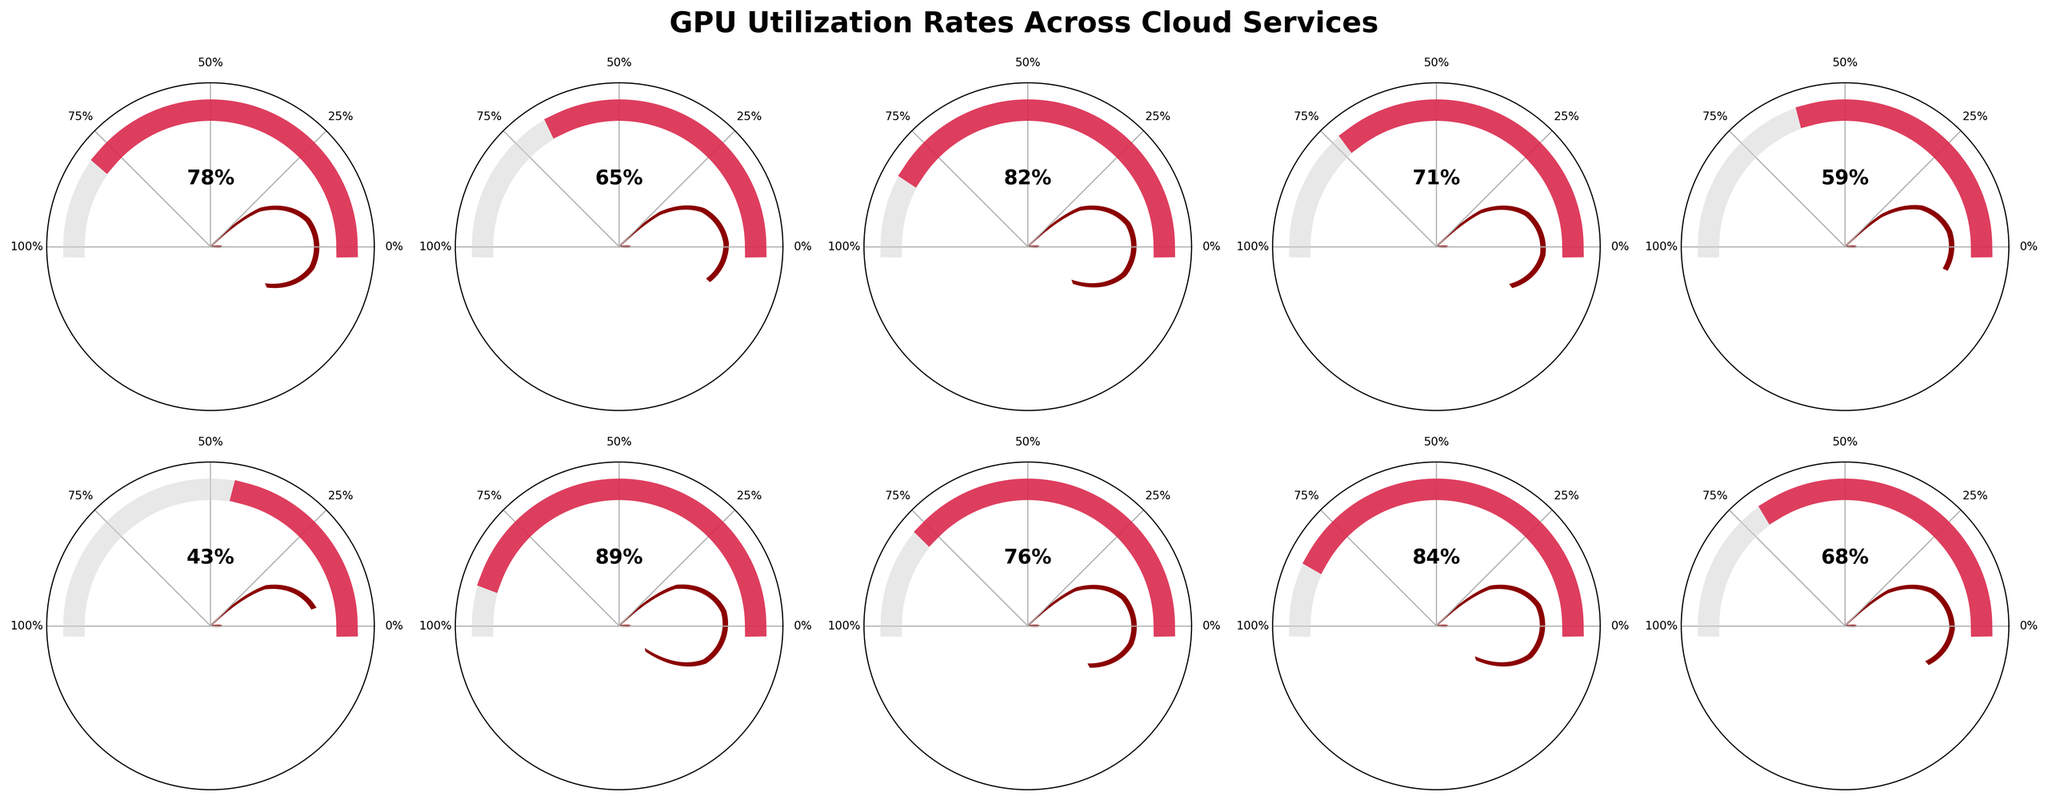What's the title of the figure? The title of the figure is shown at the top. It reads 'GPU Utilization Rates Across Cloud Services'.
Answer: GPU Utilization Rates Across Cloud Services How many cloud services are visualized in the figure? There are 10 different gauge charts displayed, each representing a distinct cloud service. So, there are 10 cloud services.
Answer: 10 Which cloud service has the highest GPU utilization rate? Looking at the gauge charts, AWS SageMaker shows the highest utilization rate, indicated by the needle at 89%.
Answer: AWS SageMaker What is the average GPU utilization rate among the services? Add all the utilization rates: 78 (AWS EC2) + 65 (Google Cloud GPU) + 82 (Azure GPU) + 71 (IBM Cloud GPU) + 59 (Oracle Cloud GPU) + 43 (Alibaba Cloud GPU) + 89 (AWS SageMaker) + 76 (Google Cloud TPU) + 84 (Azure Batch AI) + 68 (IBM Watson ML) = 715. Divide by the number of services, 10: 715/10 = 71.5
Answer: 71.5 Which application type is associated with the lowest GPU utilization rate, and what is its rate? Look for the lowest value among the gauge charts, which is 43%. This is associated with Alibaba Cloud GPU, used for Blockchain applications.
Answer: Blockchain and 43% Among services used for Machine Learning, Deep Learning, and Natural Language Processing, which ranks second in GPU utilization rate? The services and their rates are AWS EC2 (78%), AWS SageMaker (89%), and Google Cloud TPU (76%). The second highest is AWS EC2 at 78%.
Answer: AWS EC2 Are there any services with a GPU utilization rate between 60% and 70%? The services within this range are Google Cloud GPU (Rendering) at 65% and IBM Watson Machine Learning (Speech Recognition) at 68%.
Answer: Yes What is the difference in utilization rate between the highest and lowest utilized services? The highest utilization rate is 89% (AWS SageMaker) and the lowest is 43% (Alibaba Cloud GPU). The difference is 89 - 43 = 46.
Answer: 46 How many services have a GPU utilization rate of 80% or higher? The services with utilization rates of 80% or higher are Azure GPU (82%), AWS SageMaker (89%), Azure Batch AI (84%). So, there are three such services.
Answer: 3 Is the utilization rate of GPU services for Data Analytics higher or lower compared to Machine Learning? Data Analytics (Azure GPU) has a utilization rate of 82%, whereas Machine Learning (AWS EC2) has a rate of 78%. Thus, it is higher for Data Analytics.
Answer: Higher 